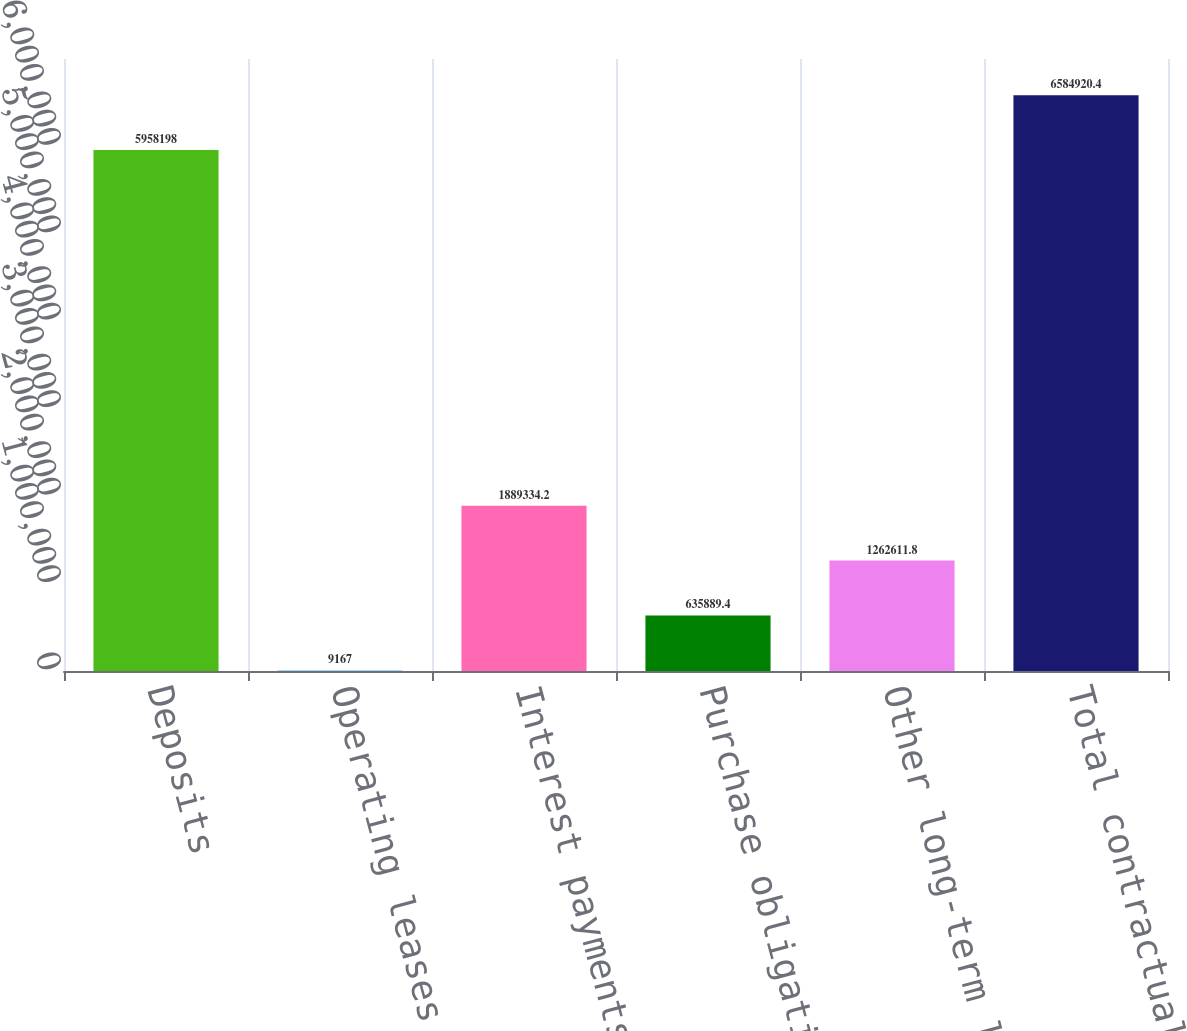Convert chart to OTSL. <chart><loc_0><loc_0><loc_500><loc_500><bar_chart><fcel>Deposits<fcel>Operating leases<fcel>Interest payments on fixed<fcel>Purchase obligations (2)<fcel>Other long-term liabilities<fcel>Total contractual obligations<nl><fcel>5.9582e+06<fcel>9167<fcel>1.88933e+06<fcel>635889<fcel>1.26261e+06<fcel>6.58492e+06<nl></chart> 